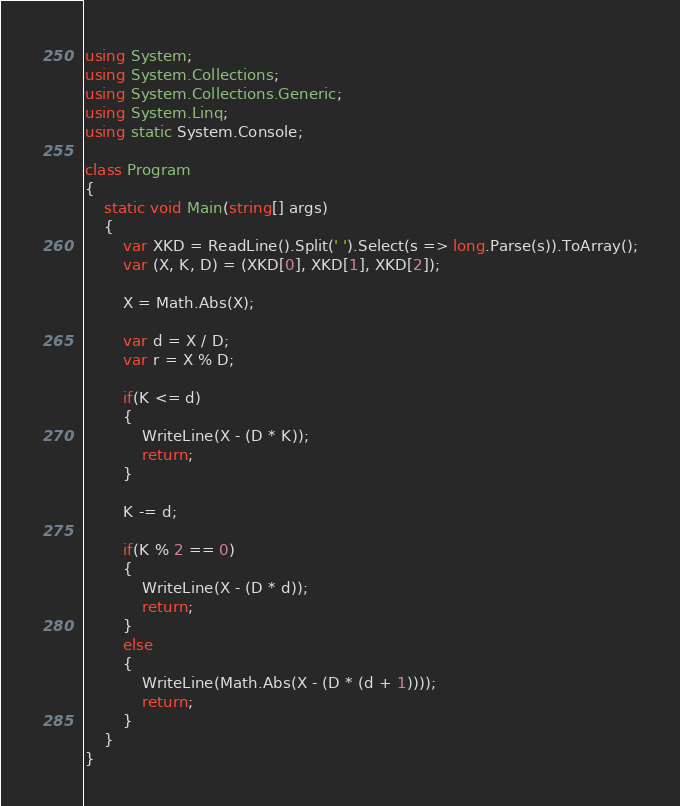Convert code to text. <code><loc_0><loc_0><loc_500><loc_500><_C#_>using System;
using System.Collections;
using System.Collections.Generic;
using System.Linq;
using static System.Console;

class Program
{
    static void Main(string[] args)
    {
        var XKD = ReadLine().Split(' ').Select(s => long.Parse(s)).ToArray();
        var (X, K, D) = (XKD[0], XKD[1], XKD[2]);

        X = Math.Abs(X);

        var d = X / D;
        var r = X % D;

        if(K <= d)
        {
            WriteLine(X - (D * K));
            return;
        }

        K -= d;

        if(K % 2 == 0)
        {
            WriteLine(X - (D * d));
            return;
        }
        else
        {
            WriteLine(Math.Abs(X - (D * (d + 1))));
            return;
        }
    }
}
</code> 